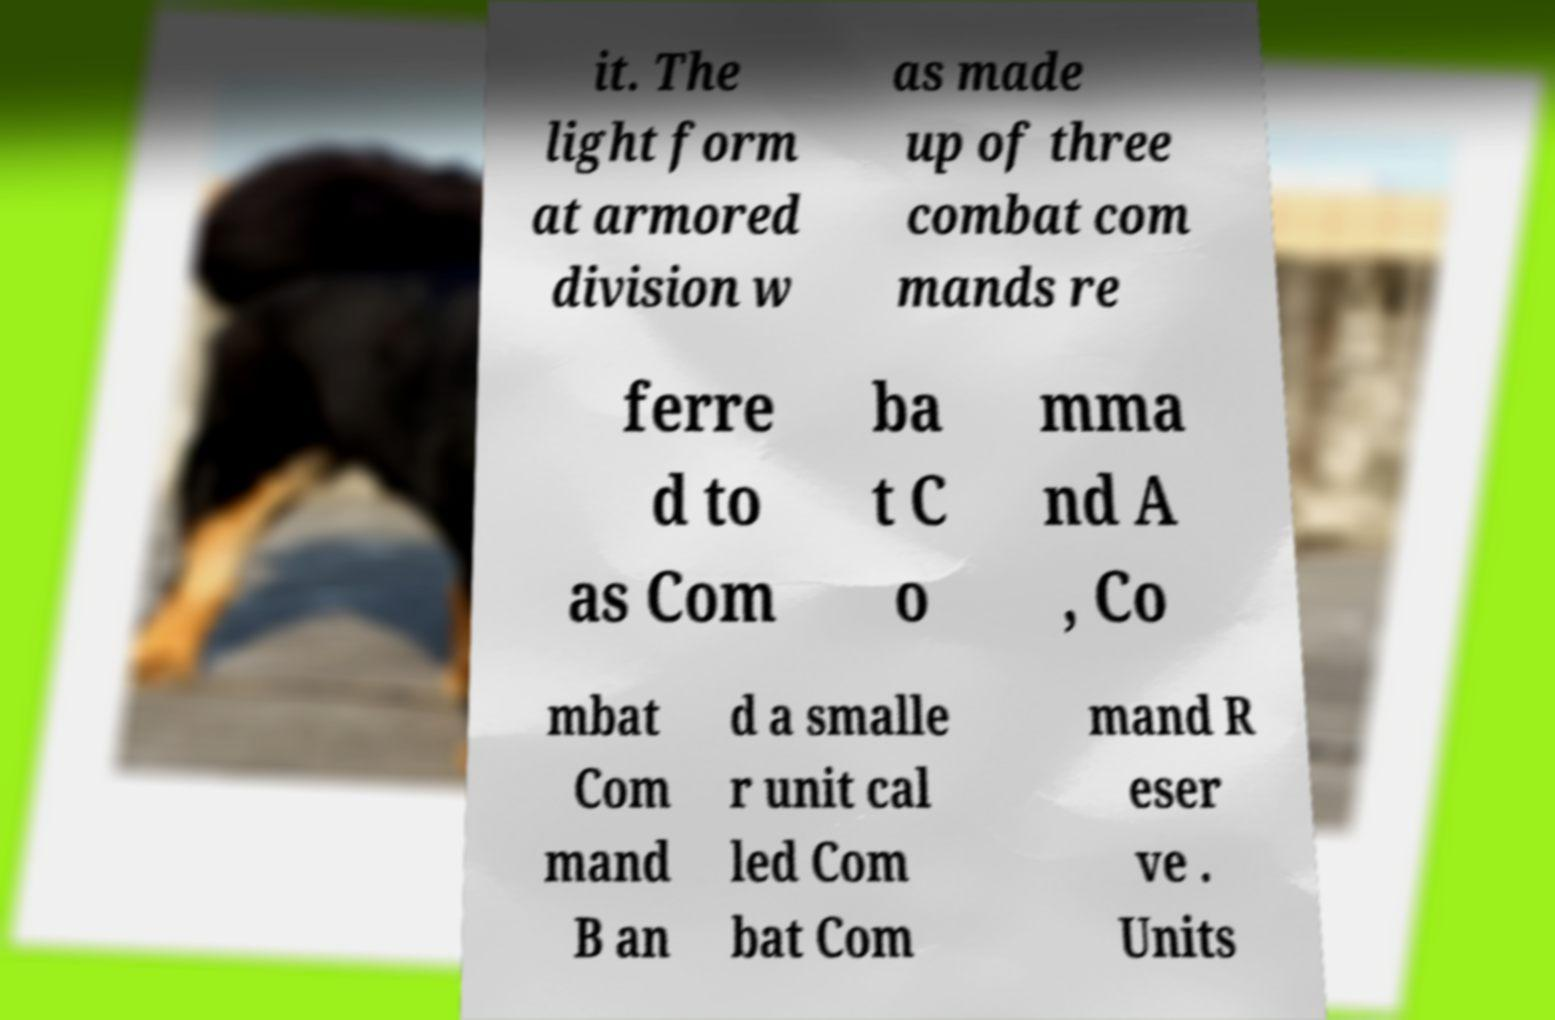Can you read and provide the text displayed in the image?This photo seems to have some interesting text. Can you extract and type it out for me? it. The light form at armored division w as made up of three combat com mands re ferre d to as Com ba t C o mma nd A , Co mbat Com mand B an d a smalle r unit cal led Com bat Com mand R eser ve . Units 